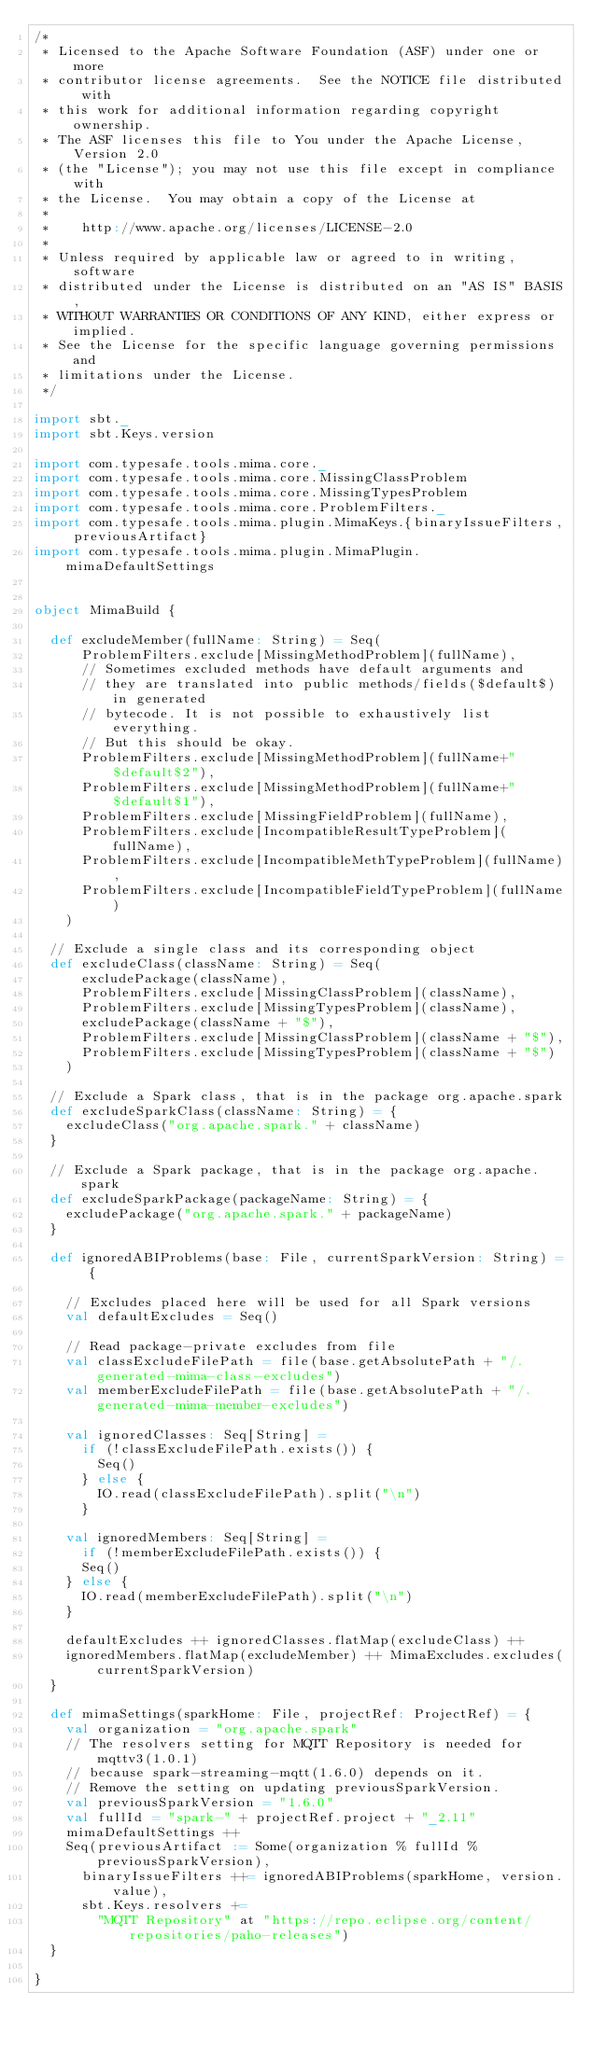<code> <loc_0><loc_0><loc_500><loc_500><_Scala_>/*
 * Licensed to the Apache Software Foundation (ASF) under one or more
 * contributor license agreements.  See the NOTICE file distributed with
 * this work for additional information regarding copyright ownership.
 * The ASF licenses this file to You under the Apache License, Version 2.0
 * (the "License"); you may not use this file except in compliance with
 * the License.  You may obtain a copy of the License at
 *
 *    http://www.apache.org/licenses/LICENSE-2.0
 *
 * Unless required by applicable law or agreed to in writing, software
 * distributed under the License is distributed on an "AS IS" BASIS,
 * WITHOUT WARRANTIES OR CONDITIONS OF ANY KIND, either express or implied.
 * See the License for the specific language governing permissions and
 * limitations under the License.
 */

import sbt._
import sbt.Keys.version

import com.typesafe.tools.mima.core._
import com.typesafe.tools.mima.core.MissingClassProblem
import com.typesafe.tools.mima.core.MissingTypesProblem
import com.typesafe.tools.mima.core.ProblemFilters._
import com.typesafe.tools.mima.plugin.MimaKeys.{binaryIssueFilters, previousArtifact}
import com.typesafe.tools.mima.plugin.MimaPlugin.mimaDefaultSettings


object MimaBuild {

  def excludeMember(fullName: String) = Seq(
      ProblemFilters.exclude[MissingMethodProblem](fullName),
      // Sometimes excluded methods have default arguments and
      // they are translated into public methods/fields($default$) in generated
      // bytecode. It is not possible to exhaustively list everything.
      // But this should be okay.
      ProblemFilters.exclude[MissingMethodProblem](fullName+"$default$2"),
      ProblemFilters.exclude[MissingMethodProblem](fullName+"$default$1"),
      ProblemFilters.exclude[MissingFieldProblem](fullName),
      ProblemFilters.exclude[IncompatibleResultTypeProblem](fullName),
      ProblemFilters.exclude[IncompatibleMethTypeProblem](fullName),
      ProblemFilters.exclude[IncompatibleFieldTypeProblem](fullName)
    )

  // Exclude a single class and its corresponding object
  def excludeClass(className: String) = Seq(
      excludePackage(className),
      ProblemFilters.exclude[MissingClassProblem](className),
      ProblemFilters.exclude[MissingTypesProblem](className),
      excludePackage(className + "$"),
      ProblemFilters.exclude[MissingClassProblem](className + "$"),
      ProblemFilters.exclude[MissingTypesProblem](className + "$")
    )

  // Exclude a Spark class, that is in the package org.apache.spark
  def excludeSparkClass(className: String) = {
    excludeClass("org.apache.spark." + className)
  }

  // Exclude a Spark package, that is in the package org.apache.spark
  def excludeSparkPackage(packageName: String) = {
    excludePackage("org.apache.spark." + packageName)
  }

  def ignoredABIProblems(base: File, currentSparkVersion: String) = {

    // Excludes placed here will be used for all Spark versions
    val defaultExcludes = Seq()

    // Read package-private excludes from file
    val classExcludeFilePath = file(base.getAbsolutePath + "/.generated-mima-class-excludes")
    val memberExcludeFilePath = file(base.getAbsolutePath + "/.generated-mima-member-excludes")

    val ignoredClasses: Seq[String] =
      if (!classExcludeFilePath.exists()) {
        Seq()
      } else {
        IO.read(classExcludeFilePath).split("\n")
      }

    val ignoredMembers: Seq[String] =
      if (!memberExcludeFilePath.exists()) {
      Seq()
    } else {
      IO.read(memberExcludeFilePath).split("\n")
    }

    defaultExcludes ++ ignoredClasses.flatMap(excludeClass) ++
    ignoredMembers.flatMap(excludeMember) ++ MimaExcludes.excludes(currentSparkVersion)
  }

  def mimaSettings(sparkHome: File, projectRef: ProjectRef) = {
    val organization = "org.apache.spark"
    // The resolvers setting for MQTT Repository is needed for mqttv3(1.0.1)
    // because spark-streaming-mqtt(1.6.0) depends on it.
    // Remove the setting on updating previousSparkVersion.
    val previousSparkVersion = "1.6.0"
    val fullId = "spark-" + projectRef.project + "_2.11"
    mimaDefaultSettings ++
    Seq(previousArtifact := Some(organization % fullId % previousSparkVersion),
      binaryIssueFilters ++= ignoredABIProblems(sparkHome, version.value),
      sbt.Keys.resolvers +=
        "MQTT Repository" at "https://repo.eclipse.org/content/repositories/paho-releases")
  }

}
</code> 